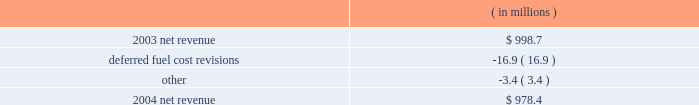Entergy arkansas , inc .
Management's financial discussion and analysis results of operations net income 2004 compared to 2003 net income increased $ 16.2 million due to lower other operation and maintenance expenses , a lower effective income tax rate for 2004 compared to 2003 , and lower interest charges .
The increase was partially offset by lower net revenue .
2003 compared to 2002 net income decreased $ 9.6 million due to lower net revenue , higher depreciation and amortization expenses , and a higher effective income tax rate for 2003 compared to 2002 .
The decrease was substantially offset by lower other operation and maintenance expenses , higher other income , and lower interest charges .
Net revenue 2004 compared to 2003 net revenue , which is entergy arkansas' measure of gross margin , consists of operating revenues net of : 1 ) fuel , fuel-related , and purchased power expenses and 2 ) other regulatory credits .
Following is an analysis of the change in net revenue comparing 2004 to 2003. .
Deferred fuel cost revisions includes the difference between the estimated deferred fuel expense and the actual calculation of recoverable fuel expense , which occurs on an annual basis .
Deferred fuel cost revisions decreased net revenue due to a revised estimate of fuel costs filed for recovery at entergy arkansas in the march 2004 energy cost recovery rider , which reduced net revenue by $ 11.5 million .
The remainder of the variance is due to the 2002 energy cost recovery true-up , made in the first quarter of 2003 , which increased net revenue in 2003 .
Gross operating revenues , fuel and purchased power expenses , and other regulatory credits gross operating revenues increased primarily due to : 2022 an increase of $ 20.7 million in fuel cost recovery revenues due to an increase in the energy cost recovery rider effective april 2004 ( fuel cost recovery revenues are discussed in note 2 to the domestic utility companies and system energy financial statements ) ; 2022 an increase of $ 15.5 million in grand gulf revenues due to an increase in the grand gulf rider effective january 2004 ; 2022 an increase of $ 13.9 million in gross wholesale revenue primarily due to increased sales to affiliated systems ; 2022 an increase of $ 9.5 million due to volume/weather primarily resulting from increased usage during the unbilled sales period , partially offset by the effect of milder weather on billed sales in 2004. .
What is the net change in net revenue during 2004 for entergy arkansas inc.? 
Computations: (978.4 - 998.7)
Answer: -20.3. 